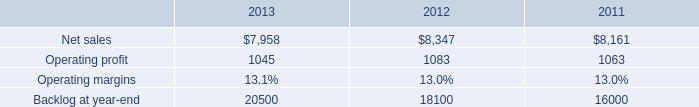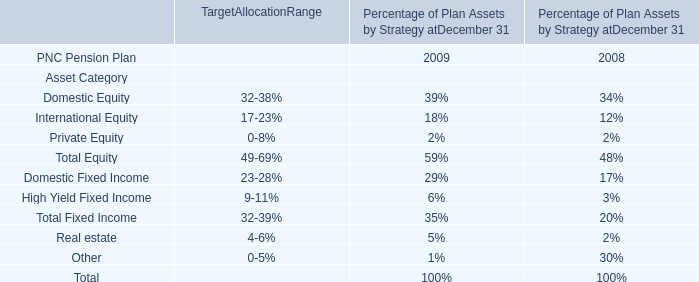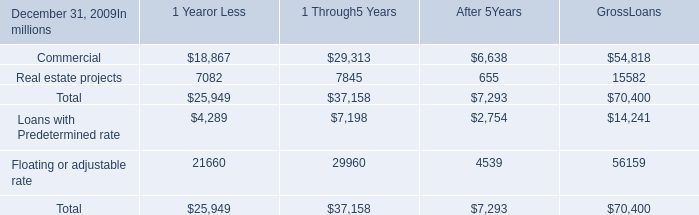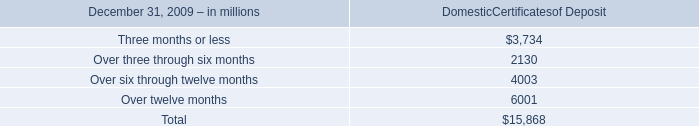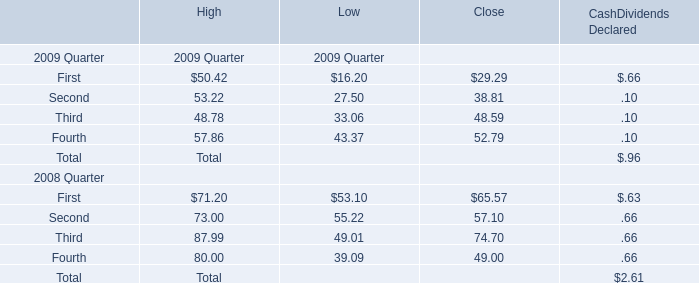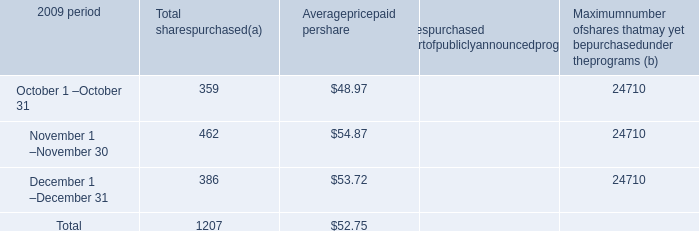In which section the sum of First has the highest value? 
Answer: High. 